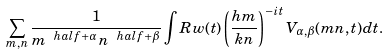Convert formula to latex. <formula><loc_0><loc_0><loc_500><loc_500>\sum _ { m , n } \frac { 1 } { m ^ { \ h a l f + \alpha } n ^ { \ h a l f + \beta } } \int R w ( t ) \left ( \frac { h m } { k n } \right ) ^ { - i t } V _ { \alpha , \beta } ( m n , t ) d t .</formula> 